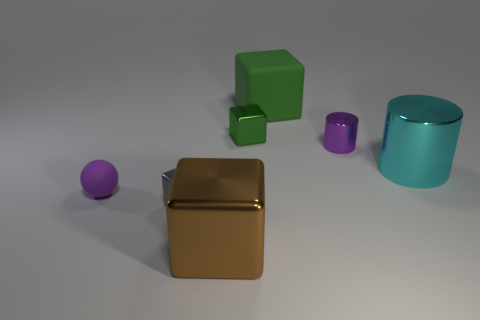Are there any tiny green objects in front of the green matte cube?
Offer a very short reply. Yes. What size is the block behind the green metal block that is behind the large object that is in front of the rubber ball?
Keep it short and to the point. Large. Does the small purple object behind the large cyan metal cylinder have the same shape as the large shiny object right of the brown thing?
Provide a short and direct response. Yes. The rubber thing that is the same shape as the large brown metal object is what size?
Provide a succinct answer. Large. How many small purple balls are made of the same material as the brown thing?
Ensure brevity in your answer.  0. What is the tiny purple cylinder made of?
Ensure brevity in your answer.  Metal. There is a matte thing that is on the left side of the big shiny object on the left side of the green rubber thing; what is its shape?
Give a very brief answer. Sphere. There is a matte object in front of the large cylinder; what shape is it?
Offer a terse response. Sphere. How many tiny metallic objects have the same color as the small rubber sphere?
Make the answer very short. 1. The large rubber object has what color?
Provide a succinct answer. Green. 